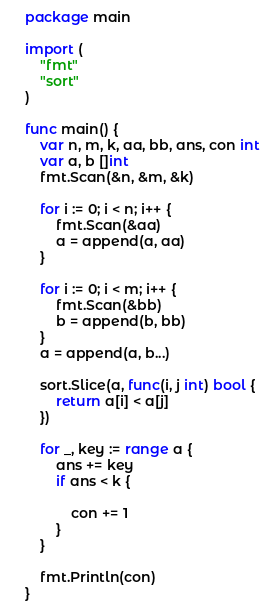Convert code to text. <code><loc_0><loc_0><loc_500><loc_500><_Go_>package main

import (
	"fmt"
	"sort"
)

func main() {
	var n, m, k, aa, bb, ans, con int
	var a, b []int
	fmt.Scan(&n, &m, &k)

	for i := 0; i < n; i++ {
		fmt.Scan(&aa)
		a = append(a, aa)
	}

	for i := 0; i < m; i++ {
		fmt.Scan(&bb)
		b = append(b, bb)
	}
	a = append(a, b...)

	sort.Slice(a, func(i, j int) bool {
		return a[i] < a[j]
	})

	for _, key := range a {
		ans += key
		if ans < k {

			con += 1
		}
	}

	fmt.Println(con)
}
</code> 